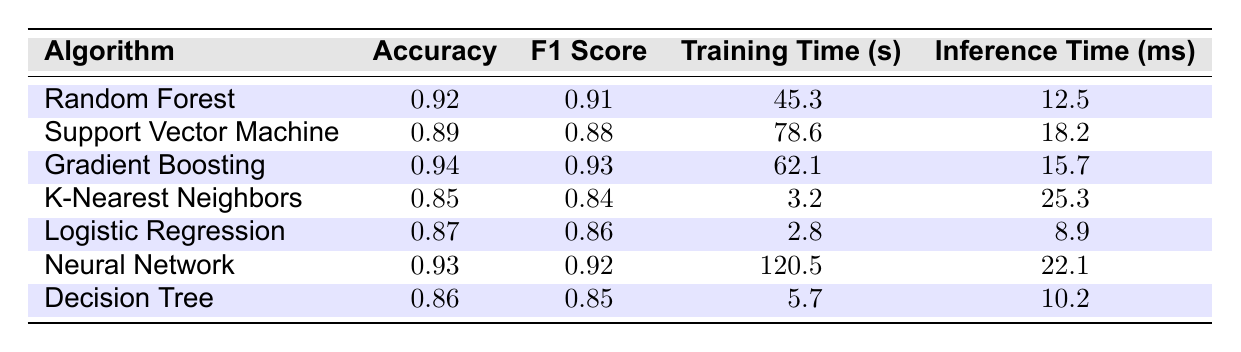What is the accuracy of the Gradient Boosting algorithm? The table lists the accuracy of the Gradient Boosting algorithm in the second column, which is given as 0.94.
Answer: 0.94 Which algorithm has the highest F1 Score? Looking at the F1 Score column, Gradient Boosting has the highest value of 0.93, followed closely by the Neural Network with 0.92.
Answer: Gradient Boosting What is the average training time of all algorithms listed? To calculate the average training time, we sum the training times: 45.3 + 78.6 + 62.1 + 3.2 + 2.8 + 120.5 + 5.7 = 318.2 seconds. The average is 318.2 / 7 = 45.5 seconds.
Answer: 45.5 Does K-Nearest Neighbors have a higher accuracy than Logistic Regression? The accuracy of K-Nearest Neighbors is 0.85 and for Logistic Regression, it is 0.87. Since 0.85 is less than 0.87, K-Nearest Neighbors does not have a higher accuracy.
Answer: No Which algorithm has the lowest inference time? Reviewing the Inference Time column, K-Nearest Neighbors has the lowest inference time of 25.3 ms compared to the others.
Answer: K-Nearest Neighbors What is the difference in training time between the Neural Network and Support Vector Machine? The training time for Neural Network is 120.5 seconds, and for Support Vector Machine, it is 78.6 seconds. The difference is 120.5 - 78.6 = 41.9 seconds.
Answer: 41.9 Is the accuracy of the Decision Tree algorithm greater than 0.85? The accuracy of Decision Tree is 0.86, which is indeed greater than 0.85.
Answer: Yes What is the total training time recorded for all algorithms? Adding up the training times: 45.3 + 78.6 + 62.1 + 3.2 + 2.8 + 120.5 + 5.7 = 318.2 seconds gives the total training time.
Answer: 318.2 